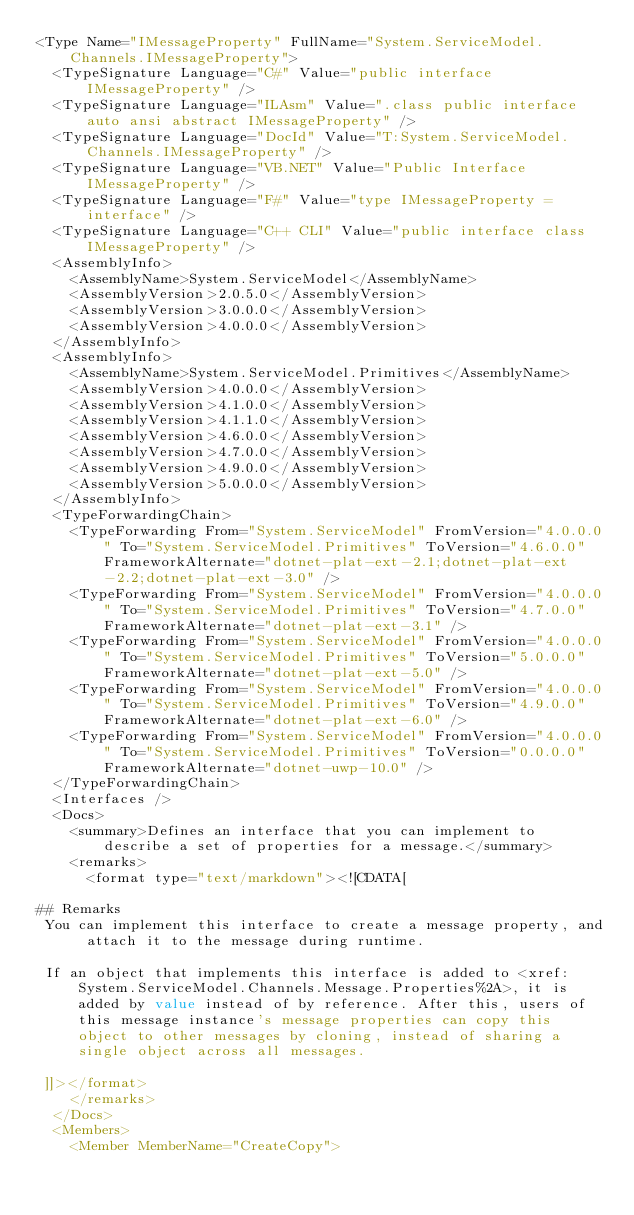Convert code to text. <code><loc_0><loc_0><loc_500><loc_500><_XML_><Type Name="IMessageProperty" FullName="System.ServiceModel.Channels.IMessageProperty">
  <TypeSignature Language="C#" Value="public interface IMessageProperty" />
  <TypeSignature Language="ILAsm" Value=".class public interface auto ansi abstract IMessageProperty" />
  <TypeSignature Language="DocId" Value="T:System.ServiceModel.Channels.IMessageProperty" />
  <TypeSignature Language="VB.NET" Value="Public Interface IMessageProperty" />
  <TypeSignature Language="F#" Value="type IMessageProperty = interface" />
  <TypeSignature Language="C++ CLI" Value="public interface class IMessageProperty" />
  <AssemblyInfo>
    <AssemblyName>System.ServiceModel</AssemblyName>
    <AssemblyVersion>2.0.5.0</AssemblyVersion>
    <AssemblyVersion>3.0.0.0</AssemblyVersion>
    <AssemblyVersion>4.0.0.0</AssemblyVersion>
  </AssemblyInfo>
  <AssemblyInfo>
    <AssemblyName>System.ServiceModel.Primitives</AssemblyName>
    <AssemblyVersion>4.0.0.0</AssemblyVersion>
    <AssemblyVersion>4.1.0.0</AssemblyVersion>
    <AssemblyVersion>4.1.1.0</AssemblyVersion>
    <AssemblyVersion>4.6.0.0</AssemblyVersion>
    <AssemblyVersion>4.7.0.0</AssemblyVersion>
    <AssemblyVersion>4.9.0.0</AssemblyVersion>
    <AssemblyVersion>5.0.0.0</AssemblyVersion>
  </AssemblyInfo>
  <TypeForwardingChain>
    <TypeForwarding From="System.ServiceModel" FromVersion="4.0.0.0" To="System.ServiceModel.Primitives" ToVersion="4.6.0.0" FrameworkAlternate="dotnet-plat-ext-2.1;dotnet-plat-ext-2.2;dotnet-plat-ext-3.0" />
    <TypeForwarding From="System.ServiceModel" FromVersion="4.0.0.0" To="System.ServiceModel.Primitives" ToVersion="4.7.0.0" FrameworkAlternate="dotnet-plat-ext-3.1" />
    <TypeForwarding From="System.ServiceModel" FromVersion="4.0.0.0" To="System.ServiceModel.Primitives" ToVersion="5.0.0.0" FrameworkAlternate="dotnet-plat-ext-5.0" />
    <TypeForwarding From="System.ServiceModel" FromVersion="4.0.0.0" To="System.ServiceModel.Primitives" ToVersion="4.9.0.0" FrameworkAlternate="dotnet-plat-ext-6.0" />
    <TypeForwarding From="System.ServiceModel" FromVersion="4.0.0.0" To="System.ServiceModel.Primitives" ToVersion="0.0.0.0" FrameworkAlternate="dotnet-uwp-10.0" />
  </TypeForwardingChain>
  <Interfaces />
  <Docs>
    <summary>Defines an interface that you can implement to describe a set of properties for a message.</summary>
    <remarks>
      <format type="text/markdown"><![CDATA[  
  
## Remarks  
 You can implement this interface to create a message property, and attach it to the message during runtime.  
  
 If an object that implements this interface is added to <xref:System.ServiceModel.Channels.Message.Properties%2A>, it is added by value instead of by reference. After this, users of this message instance's message properties can copy this object to other messages by cloning, instead of sharing a single object across all messages.  
  
 ]]></format>
    </remarks>
  </Docs>
  <Members>
    <Member MemberName="CreateCopy"></code> 